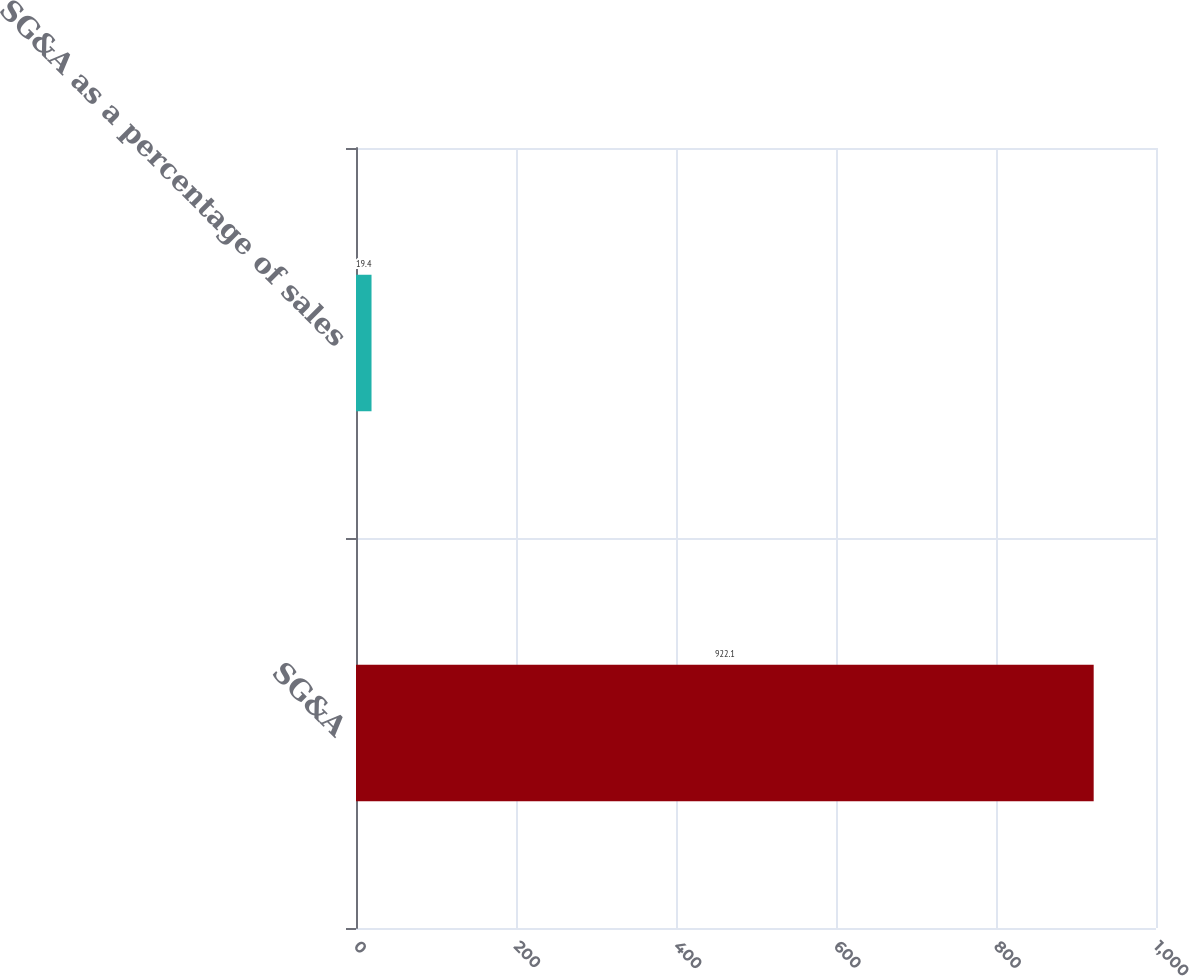Convert chart. <chart><loc_0><loc_0><loc_500><loc_500><bar_chart><fcel>SG&A<fcel>SG&A as a percentage of sales<nl><fcel>922.1<fcel>19.4<nl></chart> 